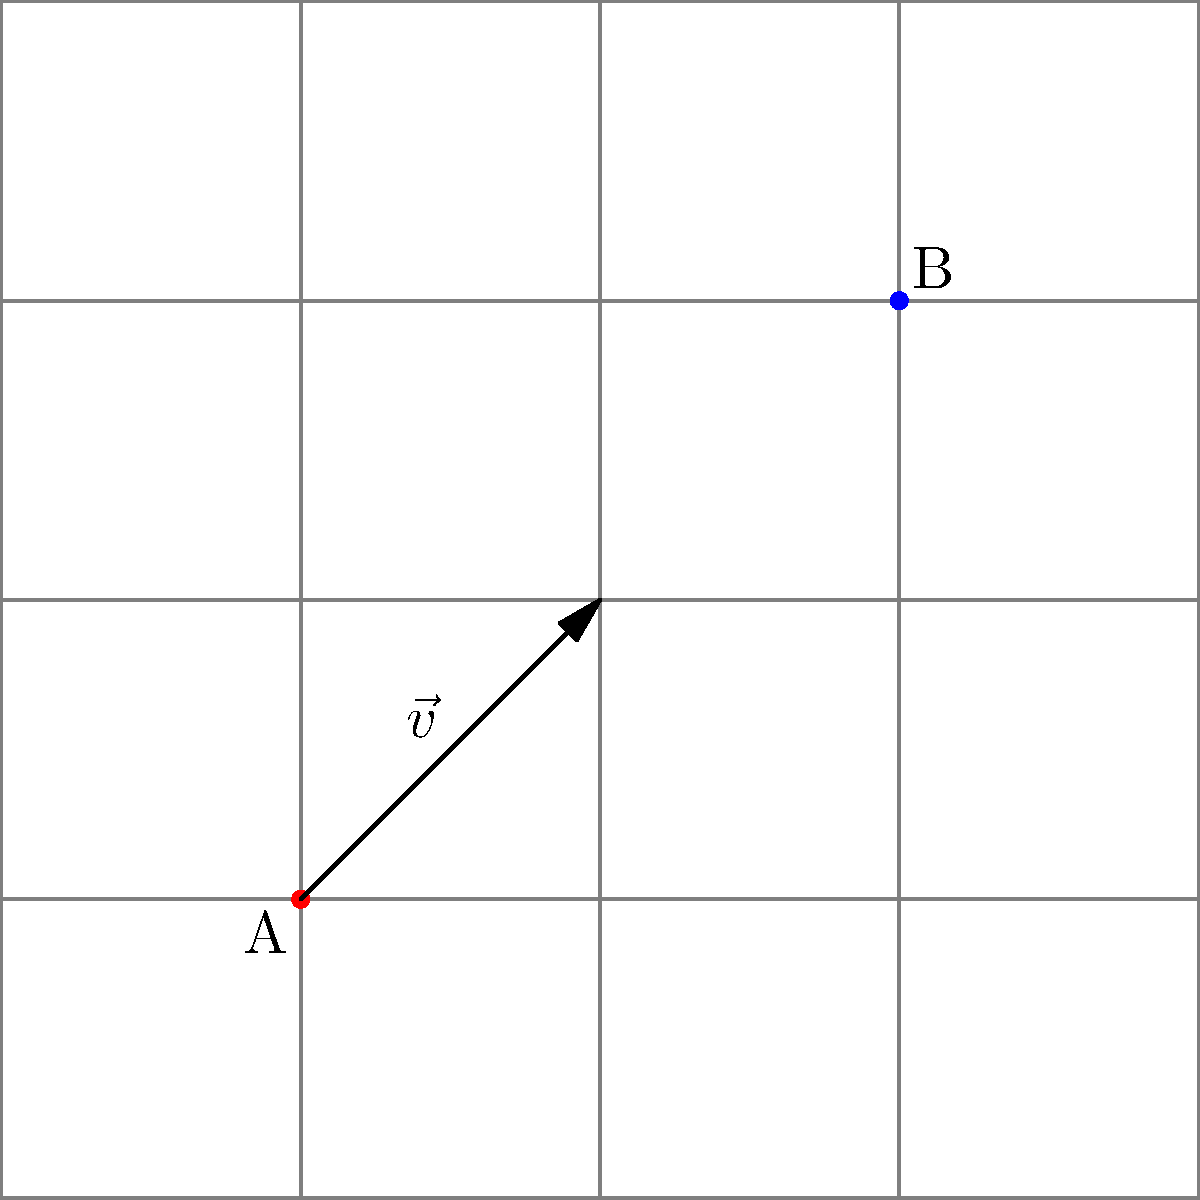As part of a traffic flow optimization project, you need to relocate traffic lights along a street grid. Traffic light A at coordinates (1,1) needs to be moved to the position of traffic light B at (3,3). What translation vector $\vec{v}$ should be applied to traffic light A to achieve this relocation? To find the translation vector $\vec{v}$ that moves traffic light A from (1,1) to (3,3), we need to follow these steps:

1. Identify the initial and final positions:
   - Initial position (traffic light A): (1,1)
   - Final position (traffic light B): (3,3)

2. Calculate the displacement in the x-direction:
   $\Delta x = x_{\text{final}} - x_{\text{initial}} = 3 - 1 = 2$

3. Calculate the displacement in the y-direction:
   $\Delta y = y_{\text{final}} - y_{\text{initial}} = 3 - 1 = 2$

4. Express the translation vector $\vec{v}$ as an ordered pair:
   $\vec{v} = (\Delta x, \Delta y) = (2, 2)$

Therefore, the translation vector $\vec{v}$ that moves traffic light A from (1,1) to (3,3) is (2,2).
Answer: $\vec{v} = (2, 2)$ 